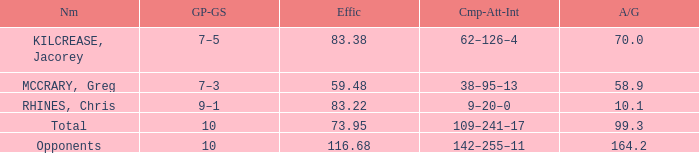What is the total avg/g of McCrary, Greg? 1.0. 